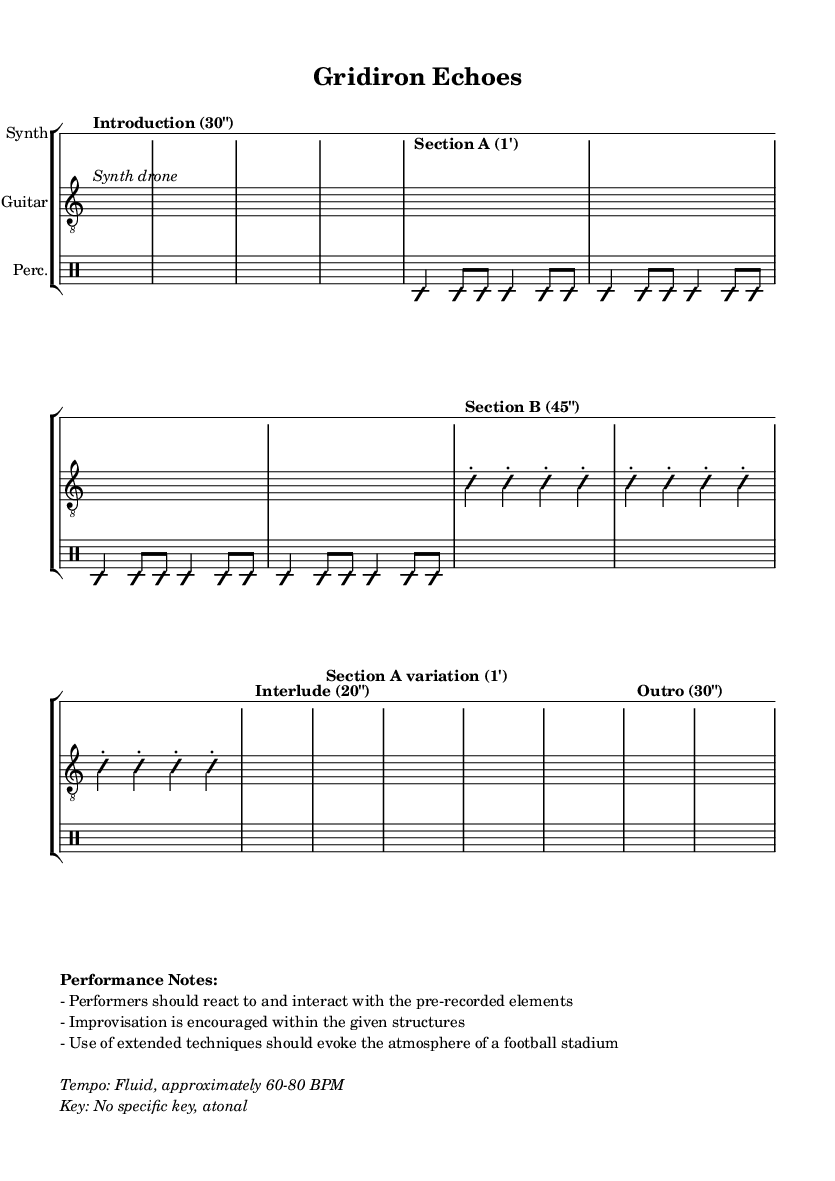What is the time signature of this music? The time signature is indicated at the beginning of the score, shown as 4/4. This means there are four beats in each measure, and a quarter note gets one beat.
Answer: 4/4 What is the specified tempo range for this piece? The tempo is indicated in the performance notes, described as fluid, approximately ranging from 60 to 80 BPM. This shows the intended speed of the piece.
Answer: 60-80 BPM How long is Section A of the music? Section A is marked with a notation indicating it lasts for 1 minute (1'). This is primarily noted in the section label, which provides the duration explicitly.
Answer: 1' What instruments are used in this composition? The score has three staff groups labeled as Synth, Guitar, and Percussion. These are listed at the beginning of each staff and represent the instruments to be used.
Answer: Synth, Guitar, Percussion What is the performance instruction related to improvisation? The performance notes specify that improvisation is encouraged within the provided structures. This instruction guides performers on how to approach their parts during the performance.
Answer: Improvisation encouraged What is suggested for the performers to evoke the atmosphere of a football stadium? The performance instructions note the use of extended techniques to evoke the atmosphere of a football stadium. This might involve various sound-producing methods beyond traditional playing techniques.
Answer: Extended techniques 